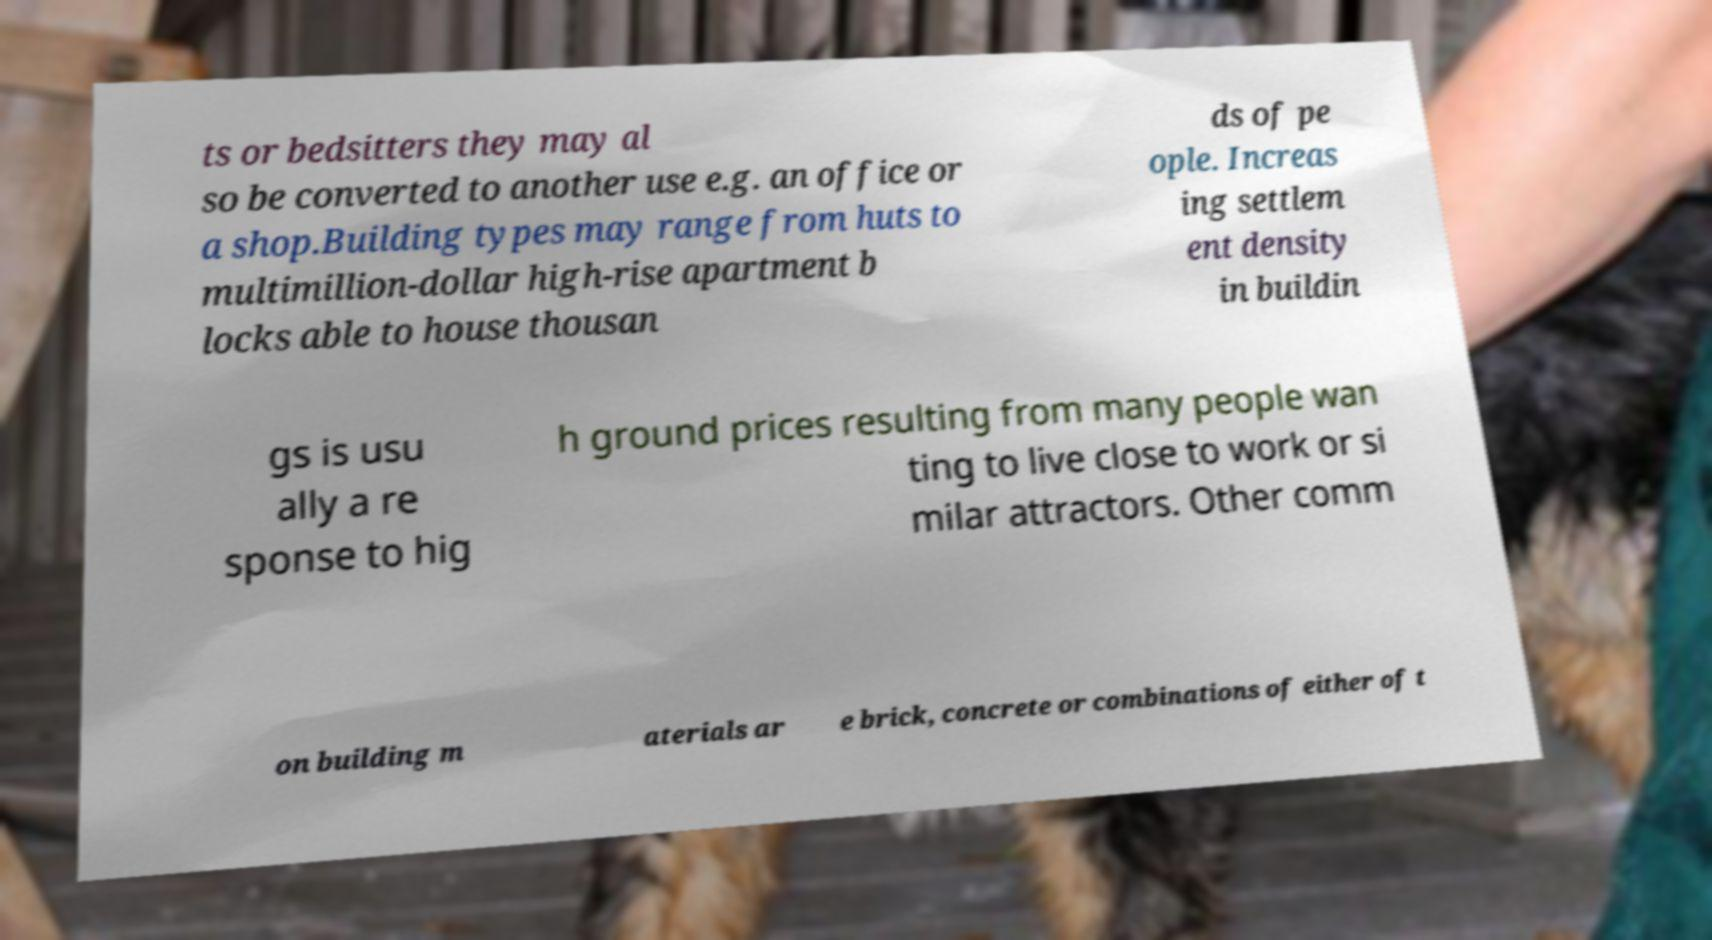For documentation purposes, I need the text within this image transcribed. Could you provide that? ts or bedsitters they may al so be converted to another use e.g. an office or a shop.Building types may range from huts to multimillion-dollar high-rise apartment b locks able to house thousan ds of pe ople. Increas ing settlem ent density in buildin gs is usu ally a re sponse to hig h ground prices resulting from many people wan ting to live close to work or si milar attractors. Other comm on building m aterials ar e brick, concrete or combinations of either of t 